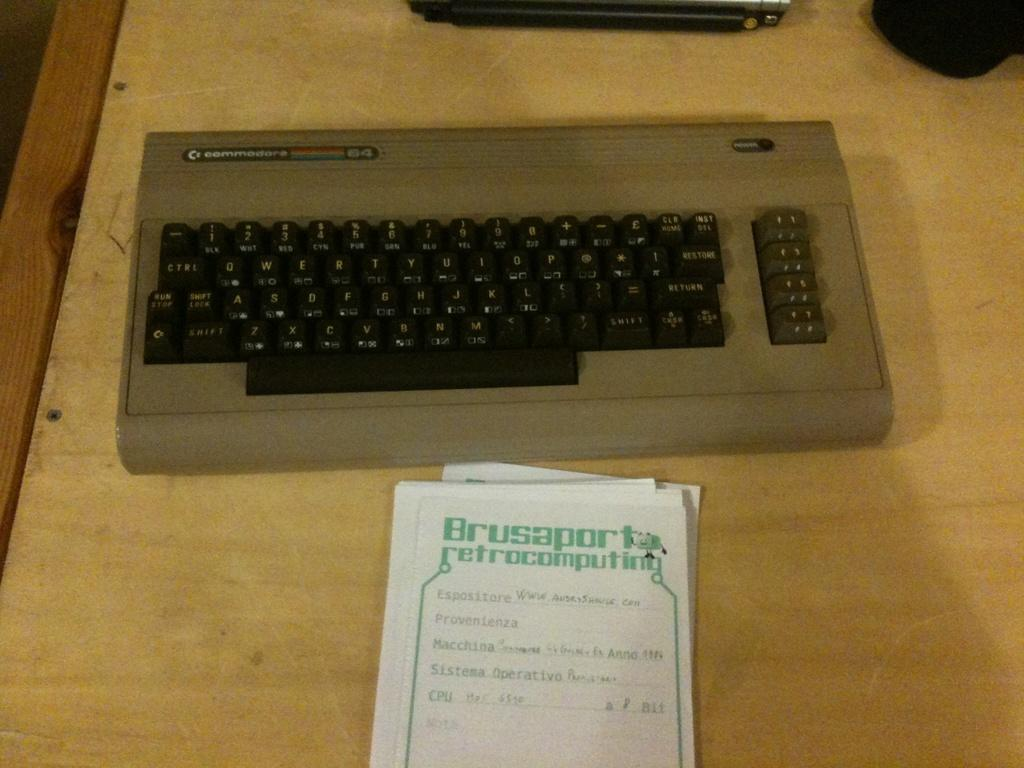<image>
Describe the image concisely. An old-fashioned keyboard with a notepad that says Brusaporta retrocomputing. 